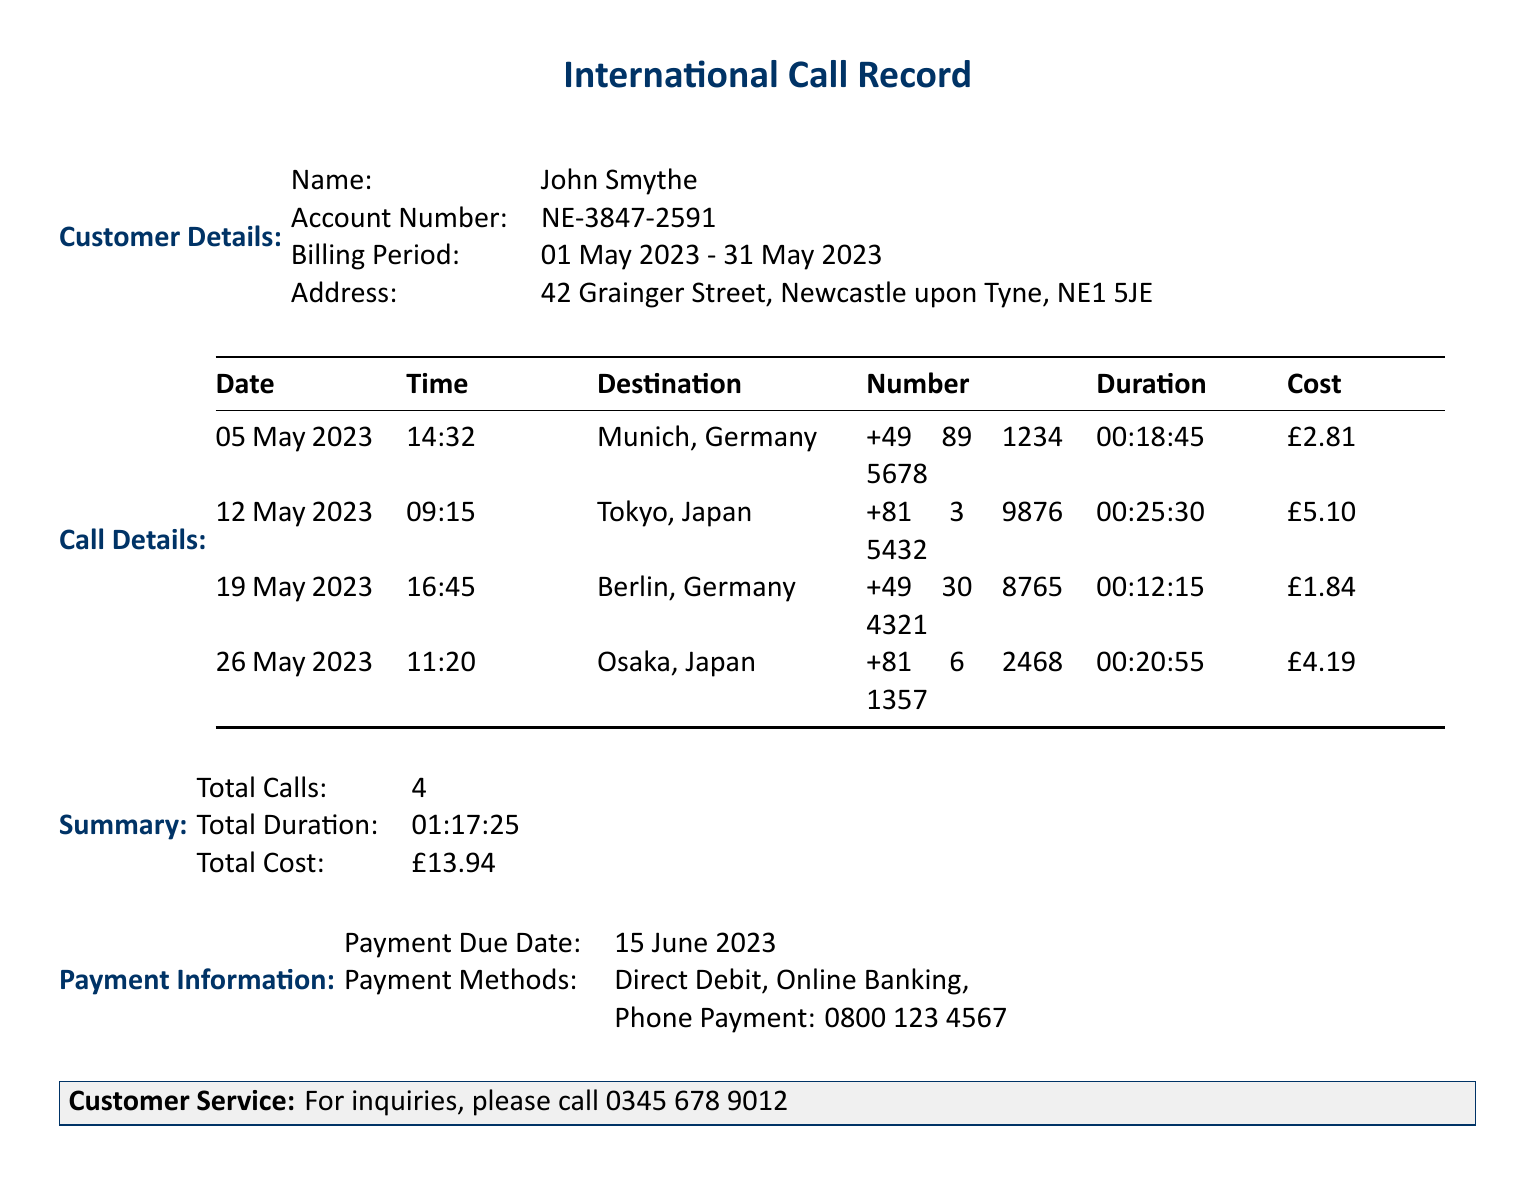What is the customer's name? The customer’s name is mentioned at the beginning of the document under Customer Details.
Answer: John Smythe What is the account number? The account number is specified in the Customer Details section of the document.
Answer: NE-3847-2591 How many calls were made in total? The total number of calls is listed in the Summary section.
Answer: 4 What was the cost of the call to Tokyo? The cost for the specific call to Tokyo is provided in the Call Details table.
Answer: £5.10 What is the total duration of all calls? The total duration can be found in the Summary section, directly indicating the cumulative duration of all calls.
Answer: 01:17:25 Which country had the least expensive call? This requires comparing the costs listed for each call in the Call Details table.
Answer: Germany What was the payment due date? The payment due date is mentioned in the Payment Information section.
Answer: 15 June 2023 How long was the call to Osaka? The duration of the call to Osaka is specified in the Call Details section.
Answer: 00:20:55 What payment methods are available? The document lists the payment methods in the Payment Information section.
Answer: Direct Debit, Online Banking, Phone Payment 